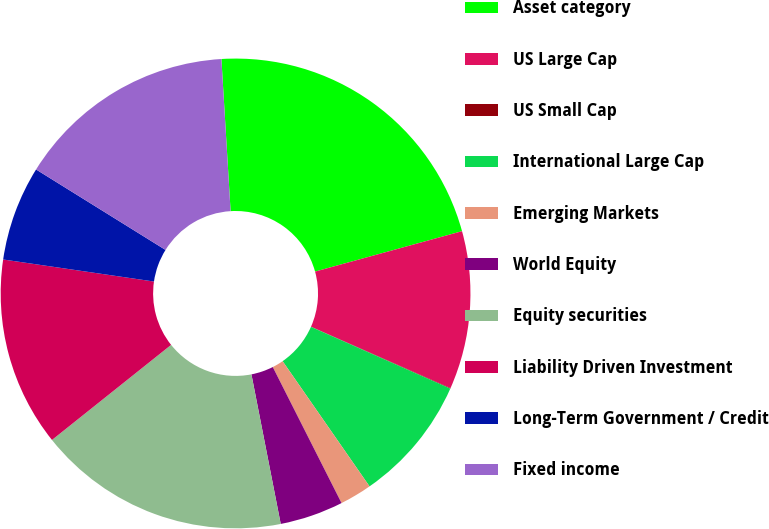<chart> <loc_0><loc_0><loc_500><loc_500><pie_chart><fcel>Asset category<fcel>US Large Cap<fcel>US Small Cap<fcel>International Large Cap<fcel>Emerging Markets<fcel>World Equity<fcel>Equity securities<fcel>Liability Driven Investment<fcel>Long-Term Government / Credit<fcel>Fixed income<nl><fcel>21.69%<fcel>10.87%<fcel>0.04%<fcel>8.7%<fcel>2.21%<fcel>4.37%<fcel>17.36%<fcel>13.03%<fcel>6.54%<fcel>15.19%<nl></chart> 